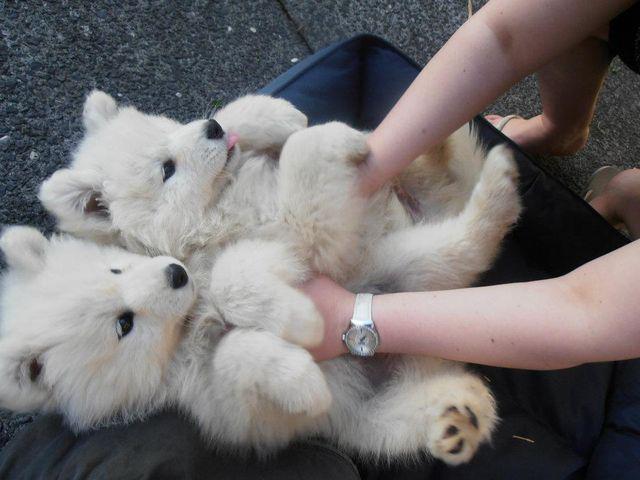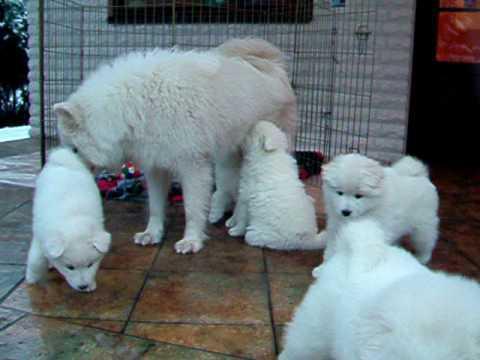The first image is the image on the left, the second image is the image on the right. Analyze the images presented: Is the assertion "At least one white dog is standing next to a person's legs." valid? Answer yes or no. No. 